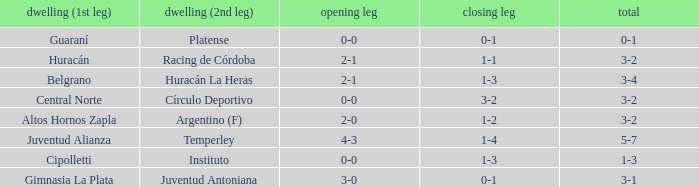What was the score of the 2nd leg when the Belgrano played the first leg at home with a score of 2-1? 1-3. Help me parse the entirety of this table. {'header': ['dwelling (1st leg)', 'dwelling (2nd leg)', 'opening leg', 'closing leg', 'total'], 'rows': [['Guaraní', 'Platense', '0-0', '0-1', '0-1'], ['Huracán', 'Racing de Córdoba', '2-1', '1-1', '3-2'], ['Belgrano', 'Huracán La Heras', '2-1', '1-3', '3-4'], ['Central Norte', 'Círculo Deportivo', '0-0', '3-2', '3-2'], ['Altos Hornos Zapla', 'Argentino (F)', '2-0', '1-2', '3-2'], ['Juventud Alianza', 'Temperley', '4-3', '1-4', '5-7'], ['Cipolletti', 'Instituto', '0-0', '1-3', '1-3'], ['Gimnasia La Plata', 'Juventud Antoniana', '3-0', '0-1', '3-1']]} 